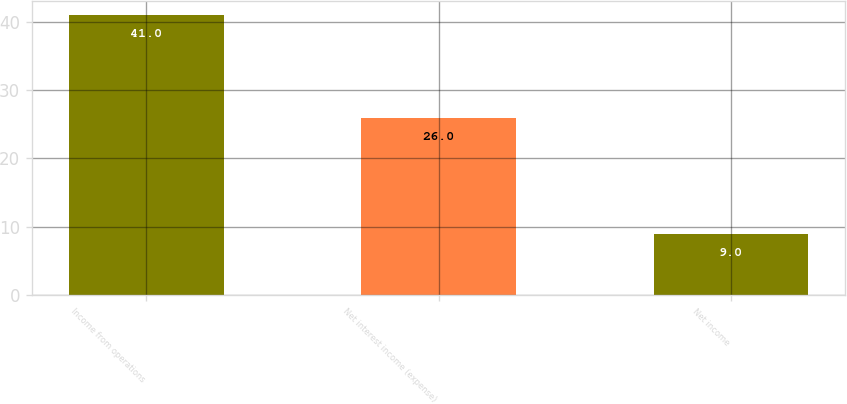<chart> <loc_0><loc_0><loc_500><loc_500><bar_chart><fcel>Income from operations<fcel>Net interest income (expense)<fcel>Net income<nl><fcel>41<fcel>26<fcel>9<nl></chart> 